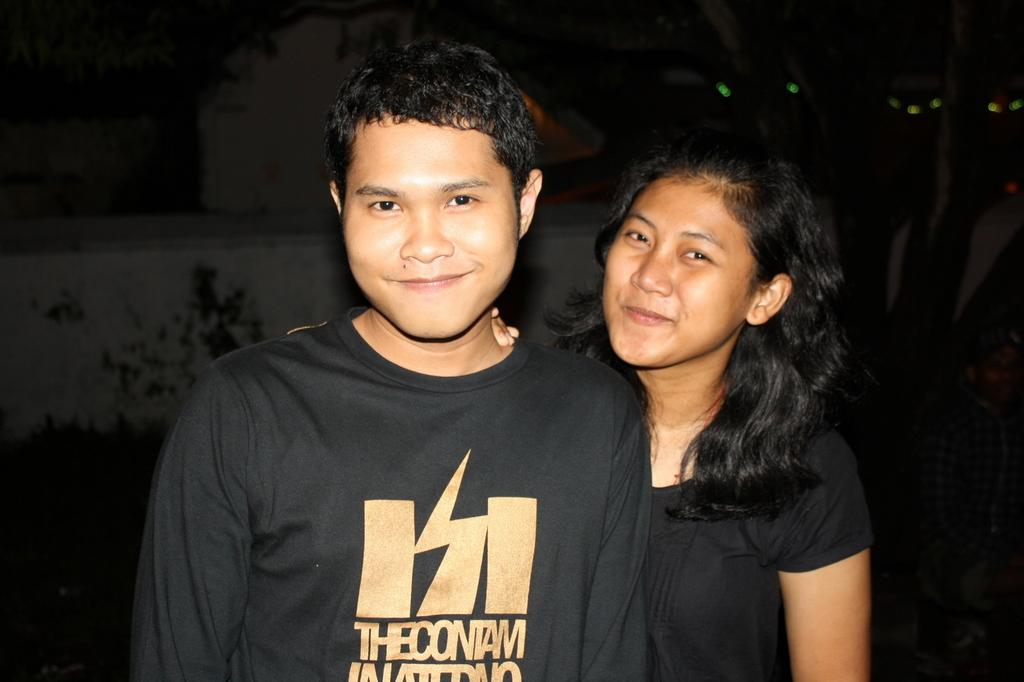Who are the people in the image? There is a man and a woman in the image. What are the expressions on their faces? Both the man and woman are smiling in the image. What can be observed about the lighting in the image? The background of the image is dark. What topic are the man and woman discussing in the image? There is no indication of a discussion taking place in the image, as it only shows the man and woman smiling. Can you tell me how many aunts are present in the image? There is no mention of an aunt in the image; it features a man and a woman. 